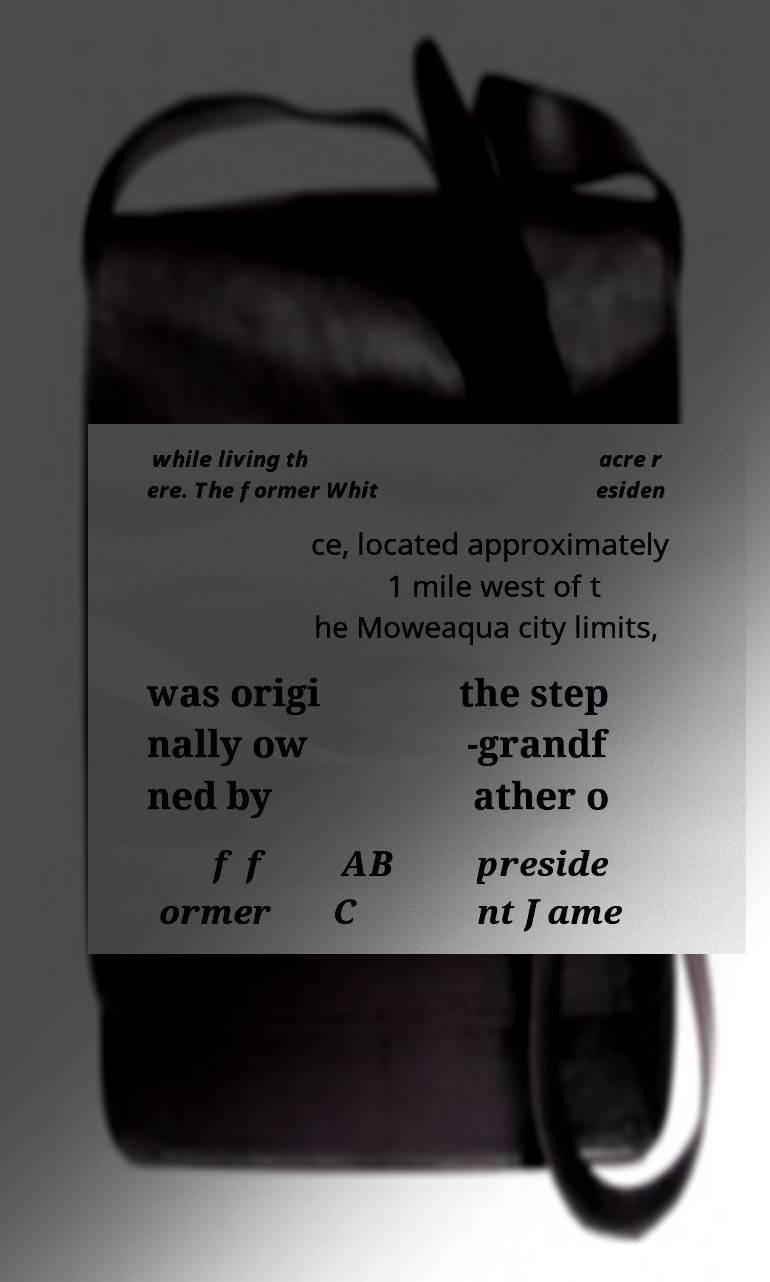For documentation purposes, I need the text within this image transcribed. Could you provide that? while living th ere. The former Whit acre r esiden ce, located approximately 1 mile west of t he Moweaqua city limits, was origi nally ow ned by the step -grandf ather o f f ormer AB C preside nt Jame 